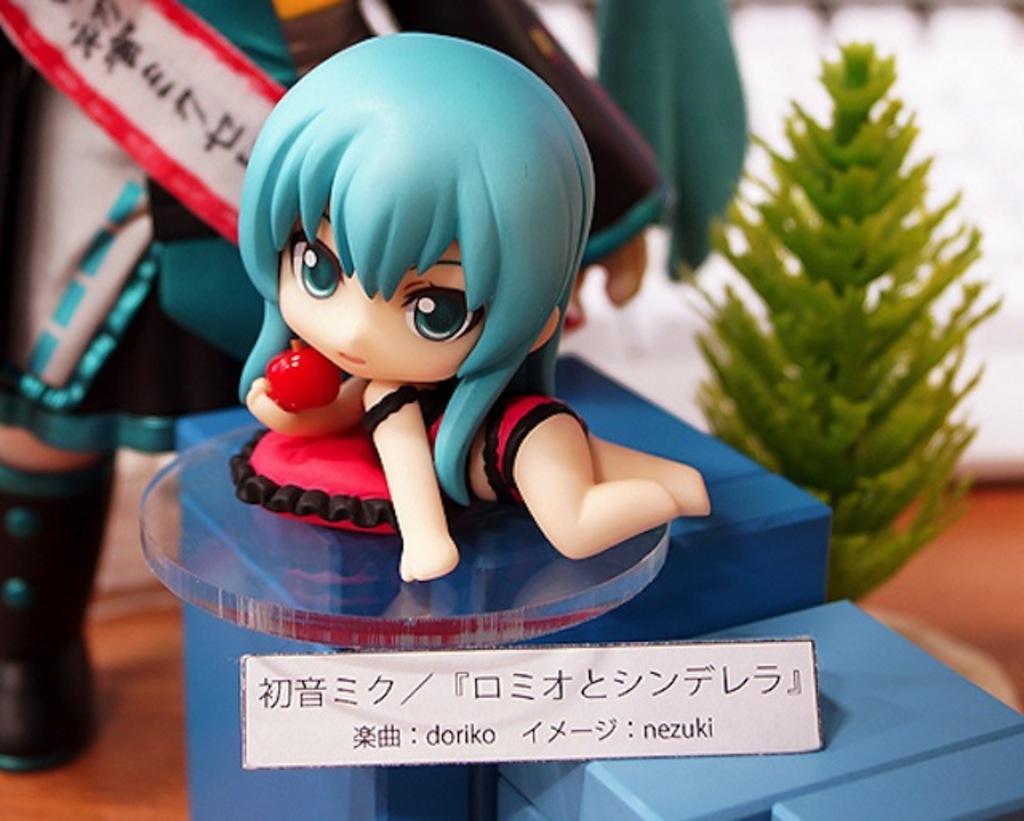Could you give a brief overview of what you see in this image? In this image I can see toys kept on blue color box and a paper attached on box and I can see a text on it and I can see a plant on the right side. 